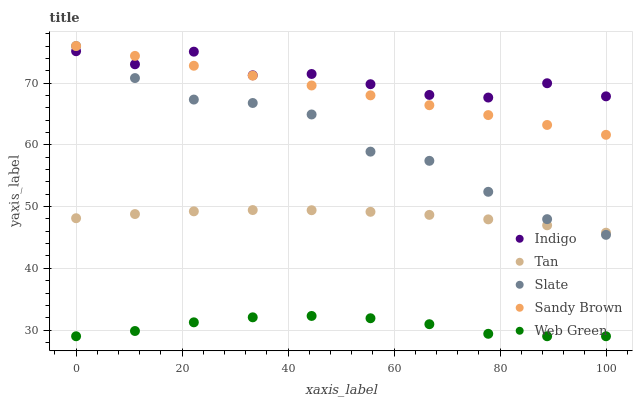Does Web Green have the minimum area under the curve?
Answer yes or no. Yes. Does Indigo have the maximum area under the curve?
Answer yes or no. Yes. Does Tan have the minimum area under the curve?
Answer yes or no. No. Does Tan have the maximum area under the curve?
Answer yes or no. No. Is Sandy Brown the smoothest?
Answer yes or no. Yes. Is Indigo the roughest?
Answer yes or no. Yes. Is Tan the smoothest?
Answer yes or no. No. Is Tan the roughest?
Answer yes or no. No. Does Web Green have the lowest value?
Answer yes or no. Yes. Does Tan have the lowest value?
Answer yes or no. No. Does Slate have the highest value?
Answer yes or no. Yes. Does Tan have the highest value?
Answer yes or no. No. Is Web Green less than Slate?
Answer yes or no. Yes. Is Sandy Brown greater than Web Green?
Answer yes or no. Yes. Does Sandy Brown intersect Indigo?
Answer yes or no. Yes. Is Sandy Brown less than Indigo?
Answer yes or no. No. Is Sandy Brown greater than Indigo?
Answer yes or no. No. Does Web Green intersect Slate?
Answer yes or no. No. 